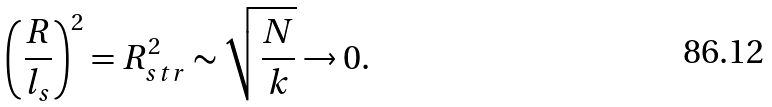<formula> <loc_0><loc_0><loc_500><loc_500>\left ( \frac { R } { l _ { s } } \right ) ^ { 2 } = R _ { s t r } ^ { 2 } \sim \sqrt { \frac { N } { k } } \rightarrow 0 .</formula> 